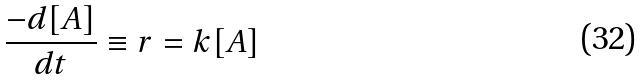Convert formula to latex. <formula><loc_0><loc_0><loc_500><loc_500>\frac { - d [ A ] } { d t } \equiv r = k [ A ]</formula> 